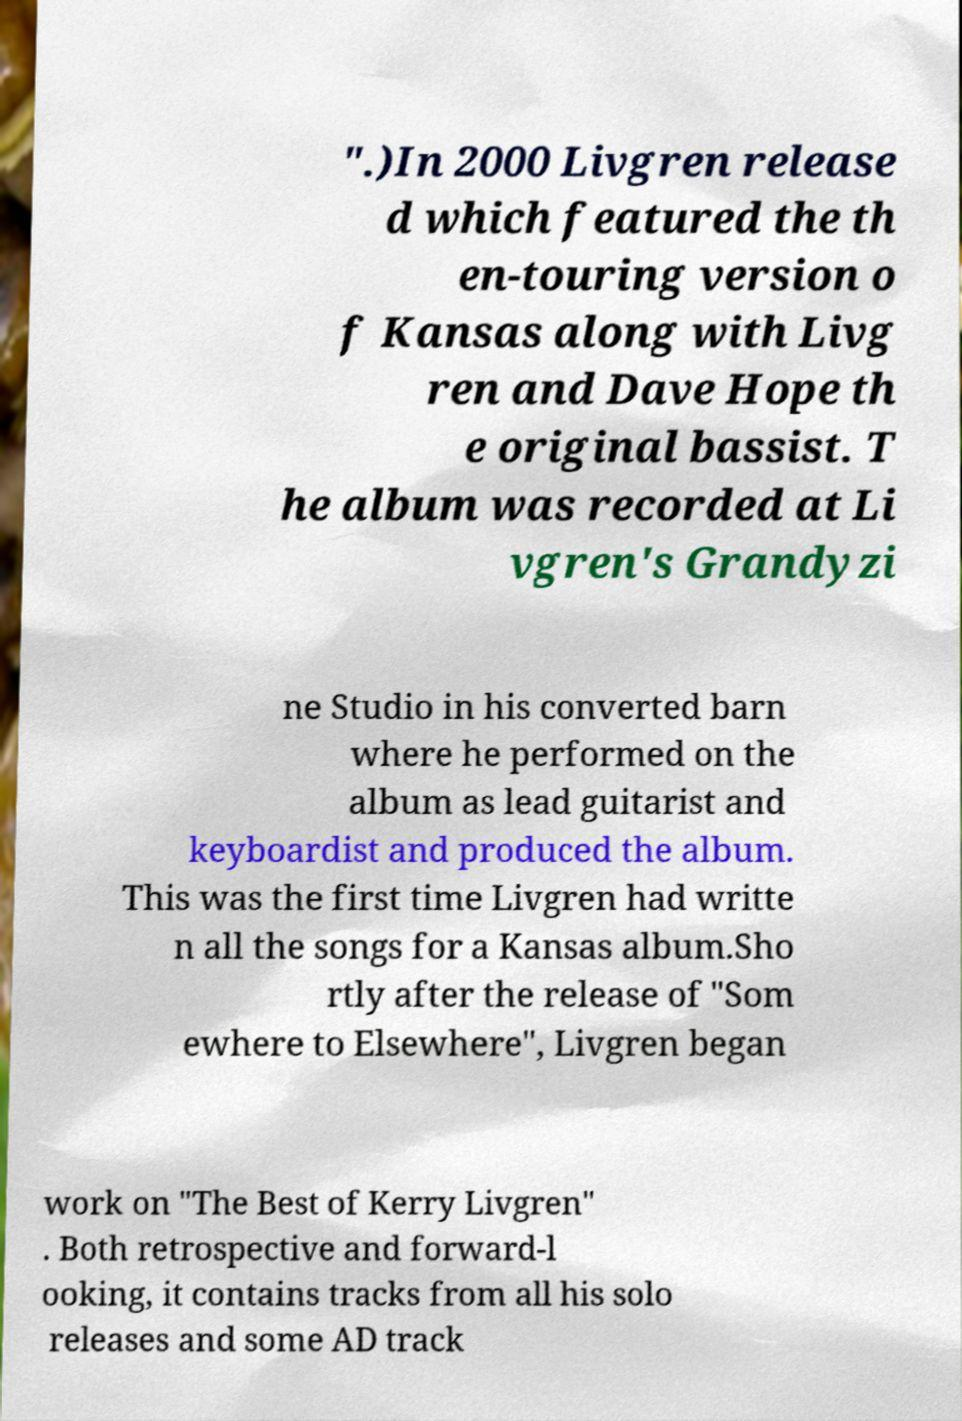Can you read and provide the text displayed in the image?This photo seems to have some interesting text. Can you extract and type it out for me? ".)In 2000 Livgren release d which featured the th en-touring version o f Kansas along with Livg ren and Dave Hope th e original bassist. T he album was recorded at Li vgren's Grandyzi ne Studio in his converted barn where he performed on the album as lead guitarist and keyboardist and produced the album. This was the first time Livgren had writte n all the songs for a Kansas album.Sho rtly after the release of "Som ewhere to Elsewhere", Livgren began work on "The Best of Kerry Livgren" . Both retrospective and forward-l ooking, it contains tracks from all his solo releases and some AD track 